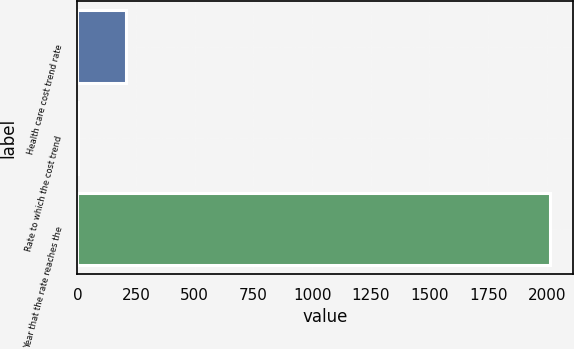Convert chart to OTSL. <chart><loc_0><loc_0><loc_500><loc_500><bar_chart><fcel>Health care cost trend rate<fcel>Rate to which the cost trend<fcel>Year that the rate reaches the<nl><fcel>205.26<fcel>4.51<fcel>2012<nl></chart> 